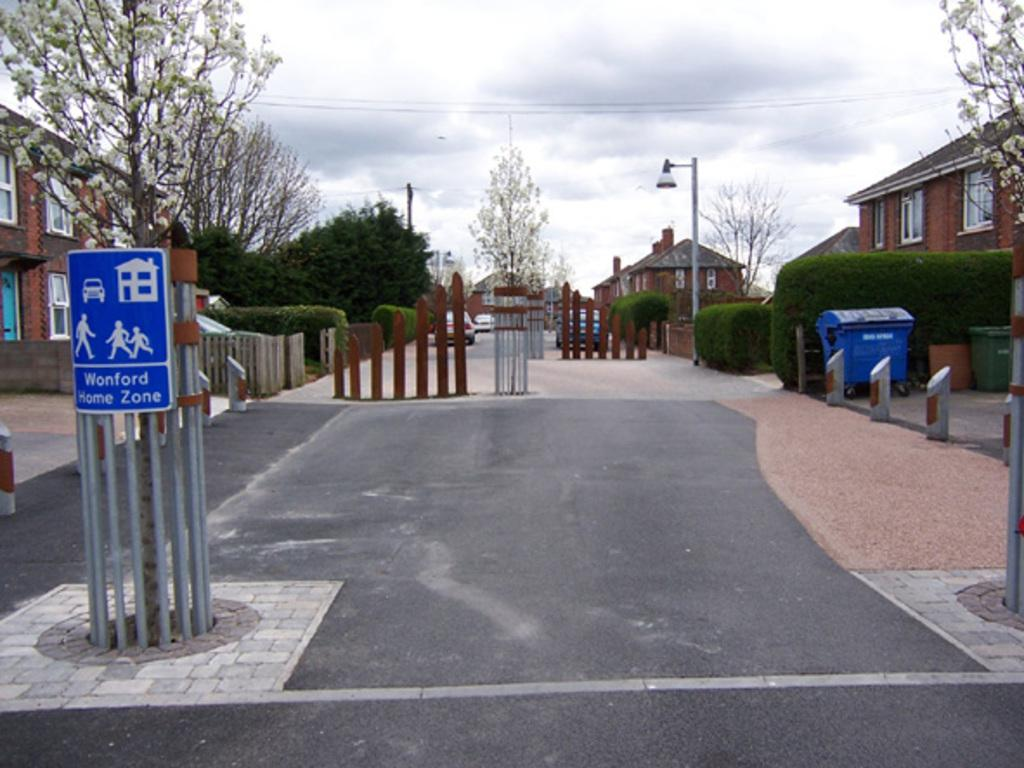Provide a one-sentence caption for the provided image. Wonford Home Zone is displayed on a sign by this crossing. 